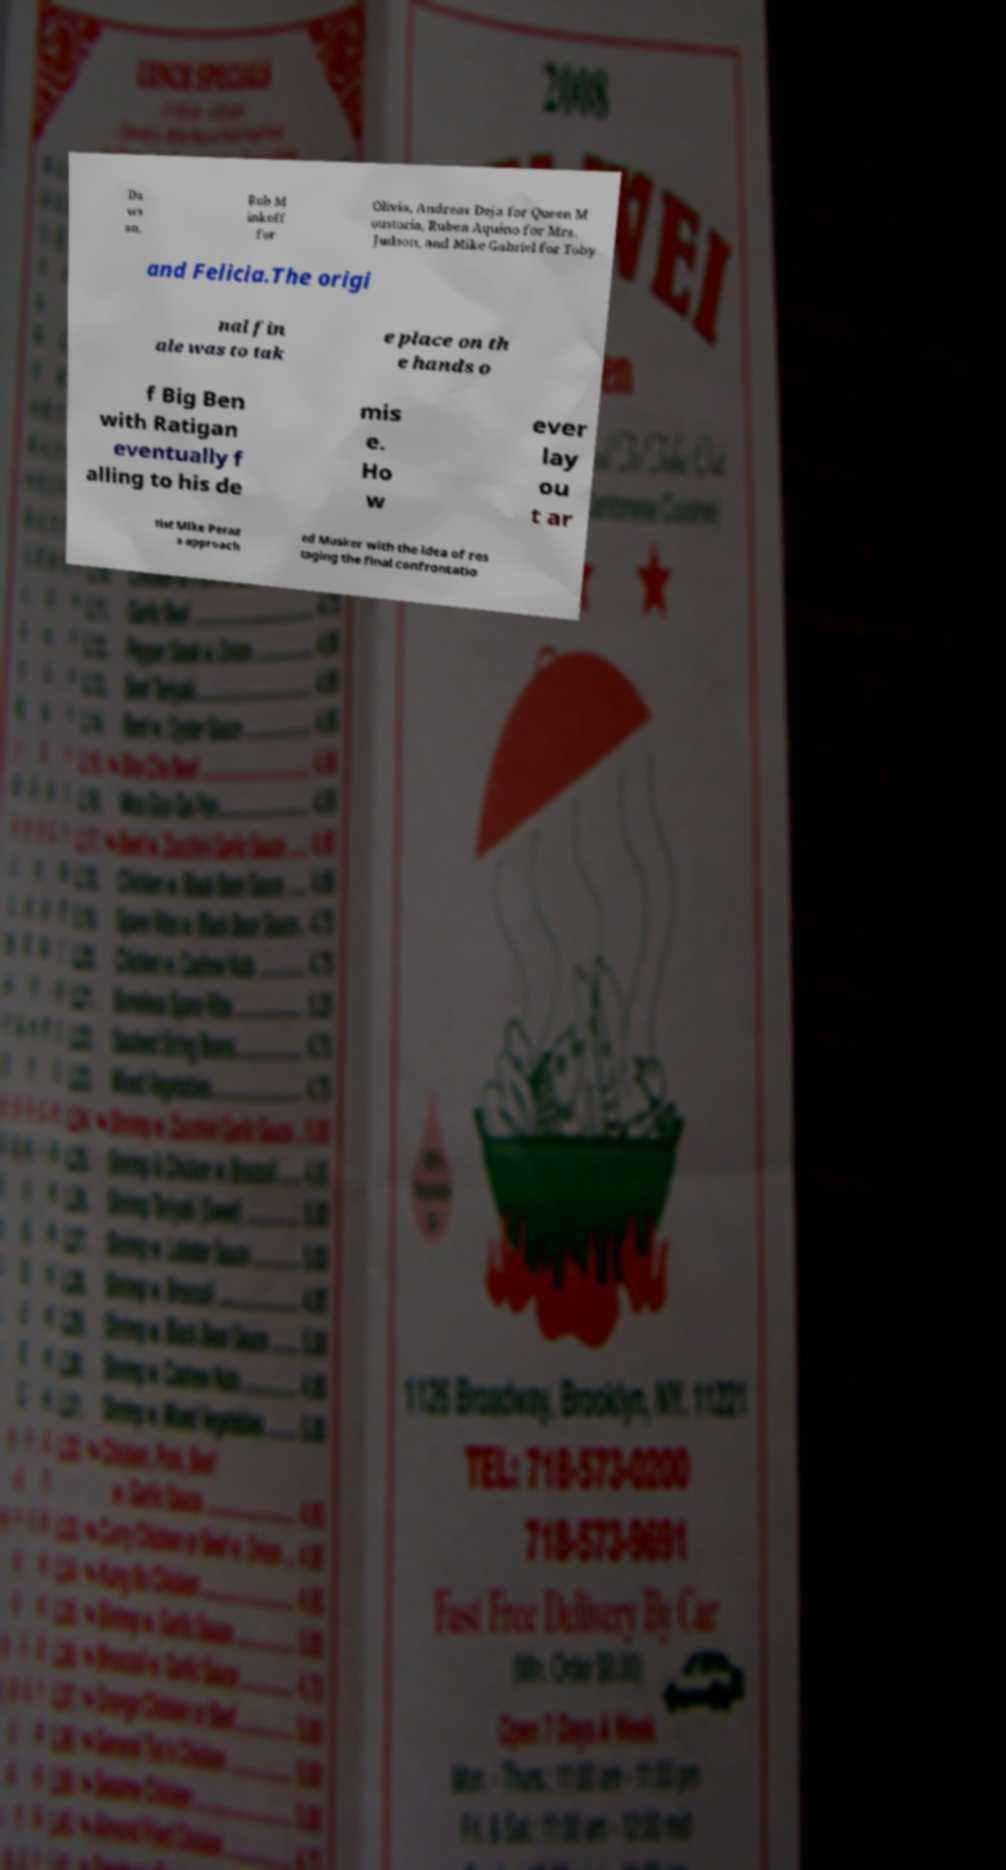Can you accurately transcribe the text from the provided image for me? Da ws on, Rob M inkoff for Olivia, Andreas Deja for Queen M oustoria, Ruben Aquino for Mrs. Judson, and Mike Gabriel for Toby and Felicia.The origi nal fin ale was to tak e place on th e hands o f Big Ben with Ratigan eventually f alling to his de mis e. Ho w ever lay ou t ar tist Mike Peraz a approach ed Musker with the idea of res taging the final confrontatio 